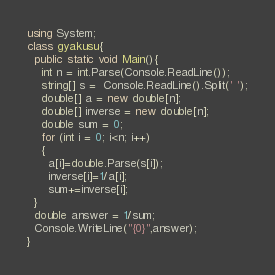Convert code to text. <code><loc_0><loc_0><loc_500><loc_500><_C#_>using System;
class gyakusu{
  public static void Main(){
    int n = int.Parse(Console.ReadLine());
    string[] s =  Console.ReadLine().Split(' ');
    double[] a = new double[n];
    double[] inverse = new double[n];
    double sum = 0;
    for (int i = 0; i<n; i++)
    {
      a[i]=double.Parse(s[i]);
      inverse[i]=1/a[i];
      sum+=inverse[i];
  }
  double answer = 1/sum;
  Console.WriteLine("{0}",answer);
}
</code> 